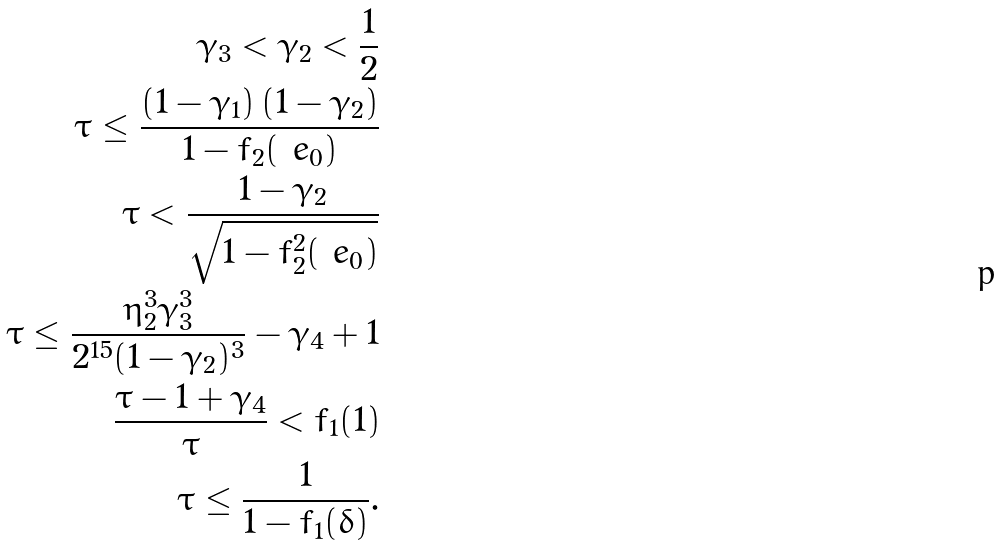Convert formula to latex. <formula><loc_0><loc_0><loc_500><loc_500>\gamma _ { 3 } < \gamma _ { 2 } < \frac { 1 } { 2 } \\ \tau \leq \frac { ( 1 - \gamma _ { 1 } ) \, ( 1 - \gamma _ { 2 } ) } { 1 - f _ { 2 } ( \ e _ { 0 } ) } \\ \tau < \frac { 1 - \gamma _ { 2 } } { \sqrt { 1 - f ^ { 2 } _ { 2 } ( \ e _ { 0 } ) } } \\ \tau \leq \frac { \eta _ { 2 } ^ { 3 } \gamma _ { 3 } ^ { 3 } } { 2 ^ { 1 5 } ( 1 - \gamma _ { 2 } ) ^ { 3 } } - \gamma _ { 4 } + 1 \\ \frac { \tau - 1 + \gamma _ { 4 } } { \tau } < f _ { 1 } ( 1 ) \\ \tau \leq \frac { 1 } { 1 - f _ { 1 } ( \delta ) } .</formula> 